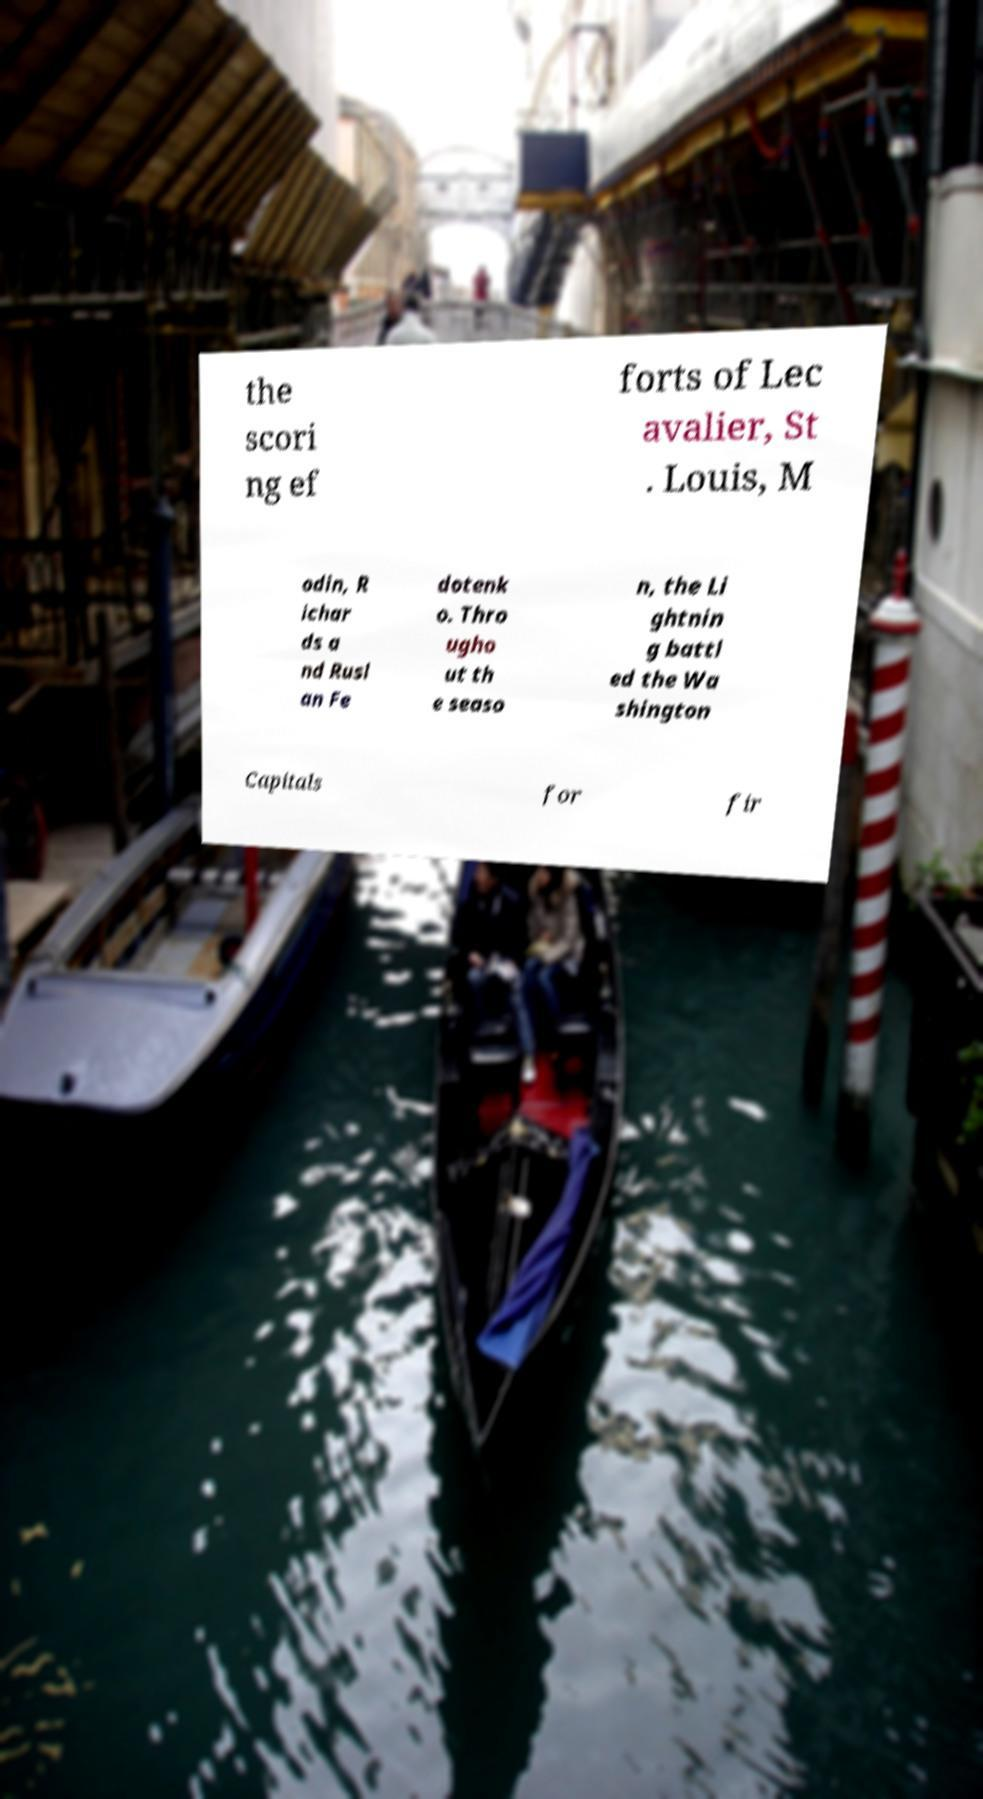Could you assist in decoding the text presented in this image and type it out clearly? the scori ng ef forts of Lec avalier, St . Louis, M odin, R ichar ds a nd Rusl an Fe dotenk o. Thro ugho ut th e seaso n, the Li ghtnin g battl ed the Wa shington Capitals for fir 